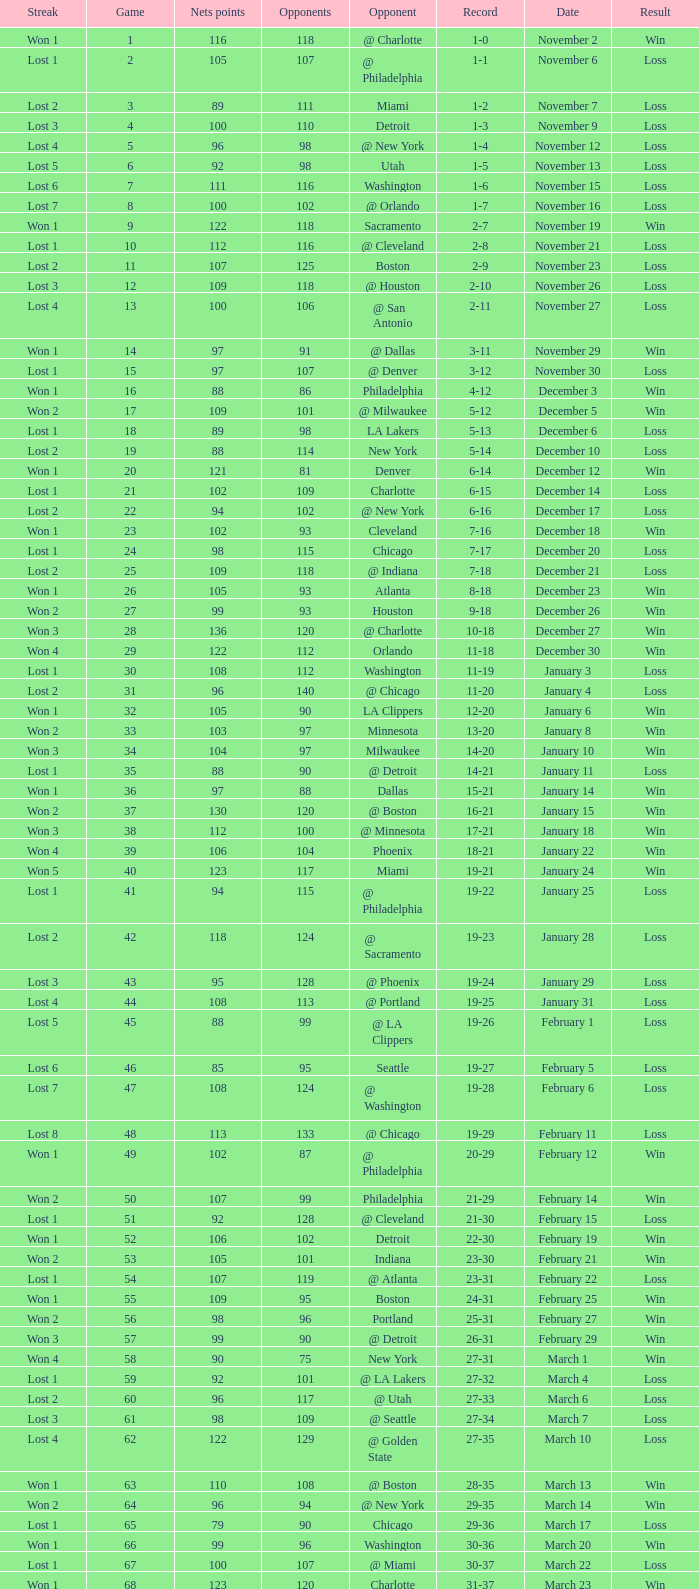Which opponent is from february 12? @ Philadelphia. 